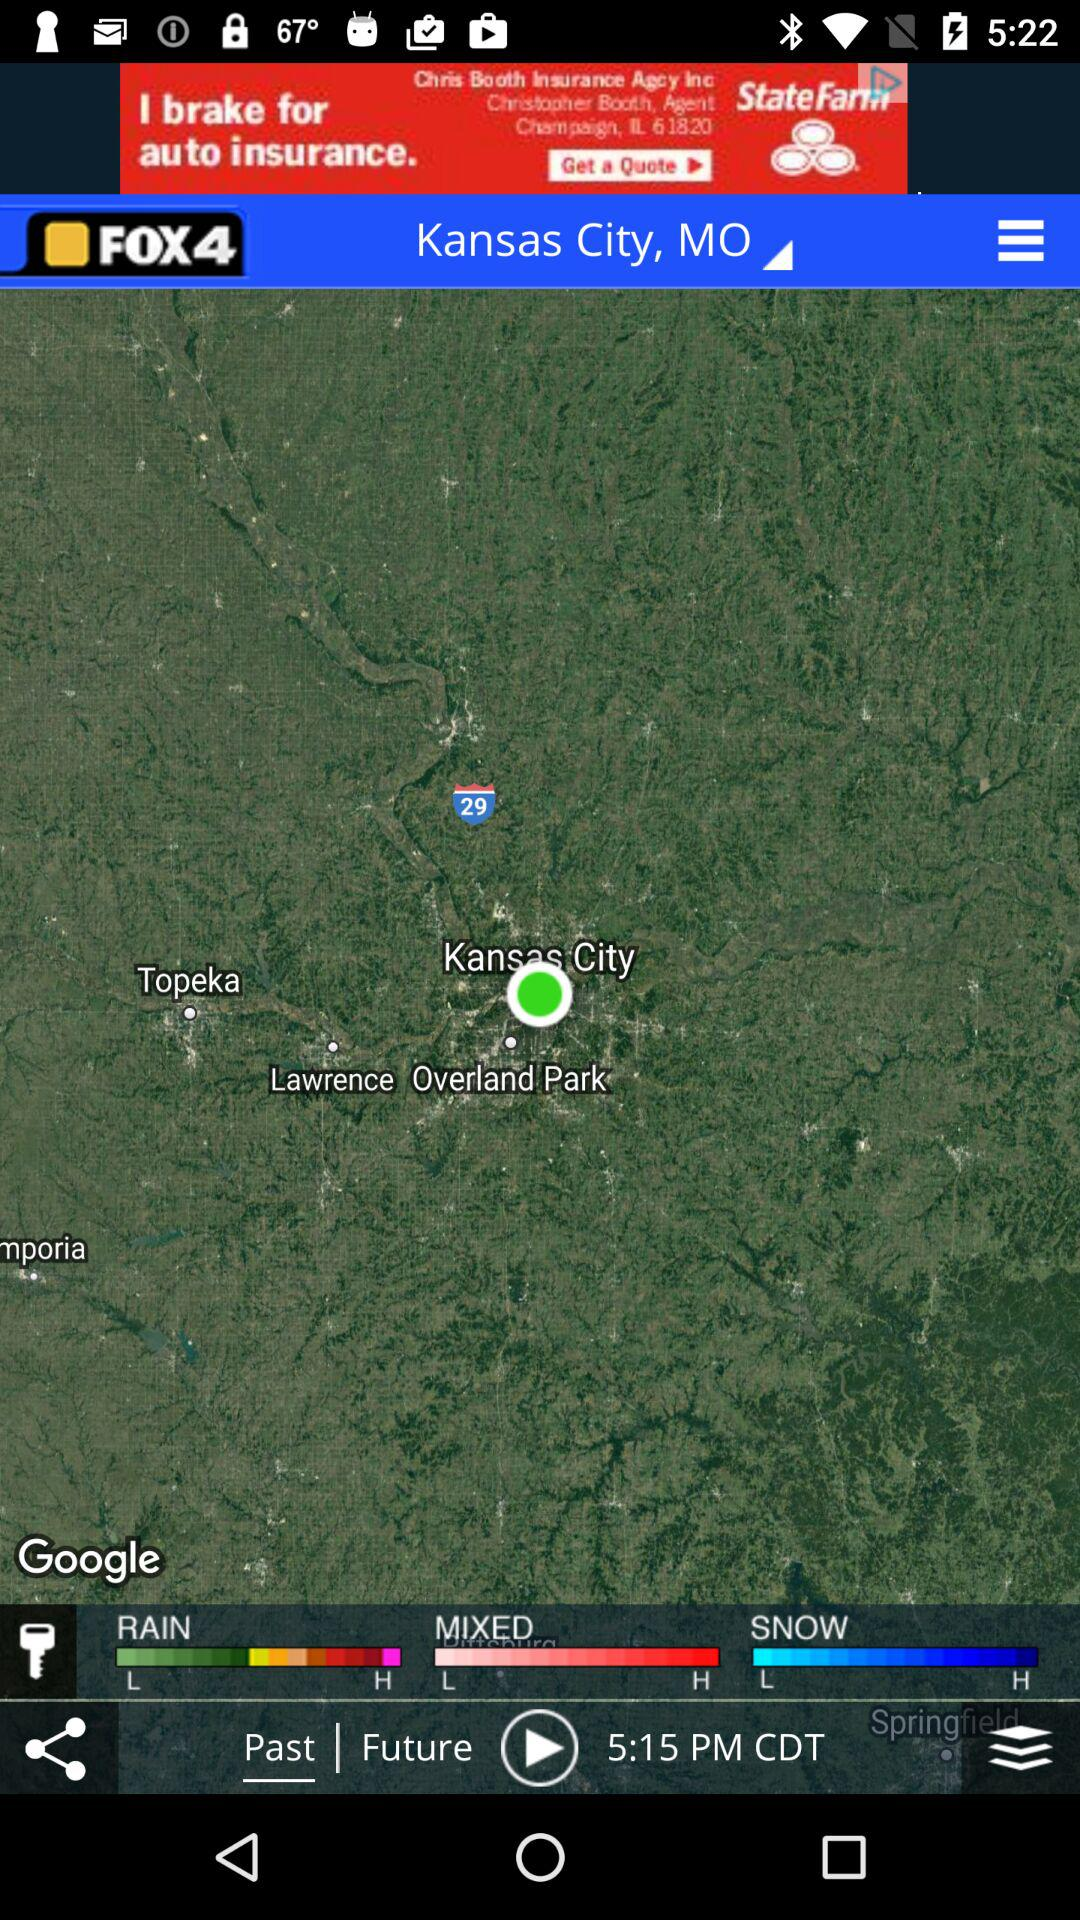How many weather conditions are displayed on the map?
Answer the question using a single word or phrase. 3 